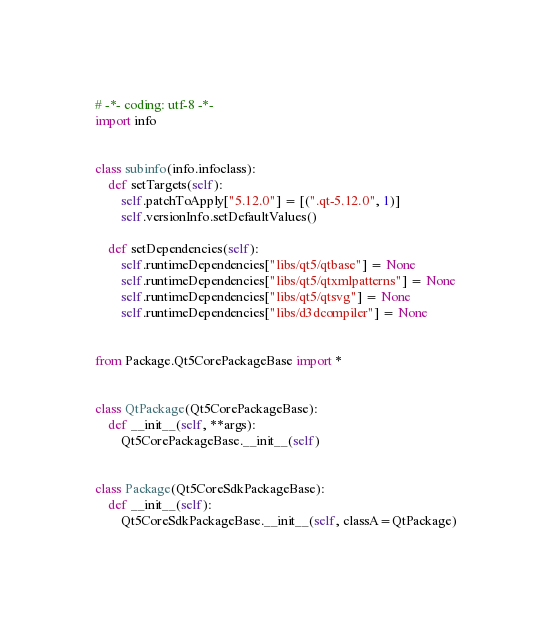<code> <loc_0><loc_0><loc_500><loc_500><_Python_># -*- coding: utf-8 -*-
import info


class subinfo(info.infoclass):
    def setTargets(self):
        self.patchToApply["5.12.0"] = [(".qt-5.12.0", 1)]
        self.versionInfo.setDefaultValues()

    def setDependencies(self):
        self.runtimeDependencies["libs/qt5/qtbase"] = None
        self.runtimeDependencies["libs/qt5/qtxmlpatterns"] = None
        self.runtimeDependencies["libs/qt5/qtsvg"] = None
        self.runtimeDependencies["libs/d3dcompiler"] = None


from Package.Qt5CorePackageBase import *


class QtPackage(Qt5CorePackageBase):
    def __init__(self, **args):
        Qt5CorePackageBase.__init__(self)


class Package(Qt5CoreSdkPackageBase):
    def __init__(self):
        Qt5CoreSdkPackageBase.__init__(self, classA=QtPackage)
</code> 